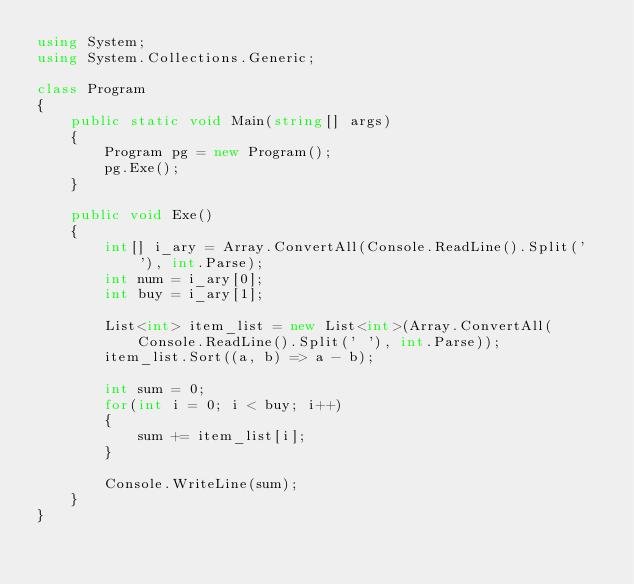Convert code to text. <code><loc_0><loc_0><loc_500><loc_500><_C#_>using System;
using System.Collections.Generic;

class Program
{
    public static void Main(string[] args)
    {
        Program pg = new Program();
        pg.Exe();
    }

    public void Exe()
    {
        int[] i_ary = Array.ConvertAll(Console.ReadLine().Split(' '), int.Parse);
        int num = i_ary[0];
        int buy = i_ary[1];

        List<int> item_list = new List<int>(Array.ConvertAll(Console.ReadLine().Split(' '), int.Parse));
        item_list.Sort((a, b) => a - b);

        int sum = 0;
        for(int i = 0; i < buy; i++)
        {
            sum += item_list[i];
        }

        Console.WriteLine(sum);
    }
}

</code> 